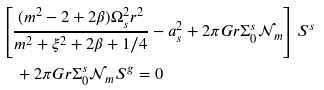Convert formula to latex. <formula><loc_0><loc_0><loc_500><loc_500>& \left [ \frac { ( m ^ { 2 } - 2 + 2 \beta ) \Omega _ { s } ^ { 2 } r ^ { 2 } } { m ^ { 2 } + \xi ^ { 2 } + 2 \beta + 1 / 4 } - a _ { s } ^ { 2 } + 2 \pi G r \Sigma _ { 0 } ^ { s } \mathcal { N } _ { m } \right ] S ^ { s } \\ & \quad + 2 \pi G r \Sigma _ { 0 } ^ { s } \mathcal { N } _ { m } S ^ { g } = 0</formula> 